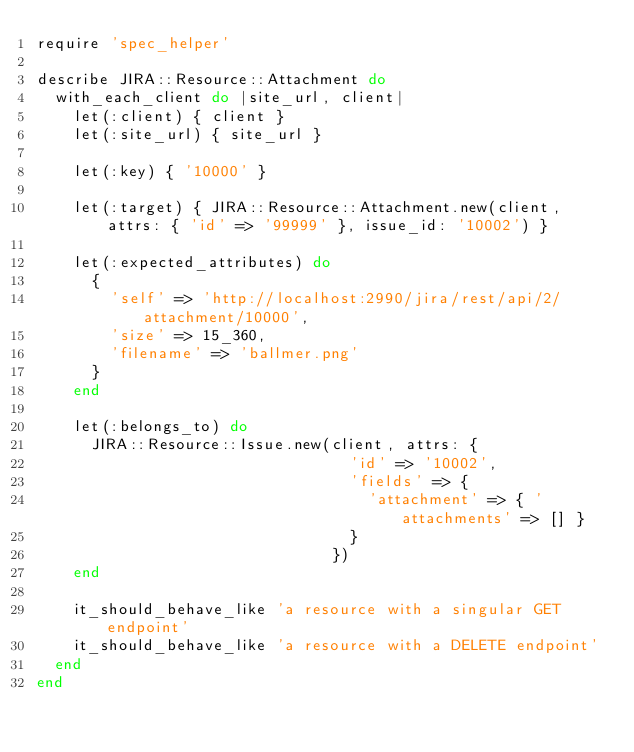<code> <loc_0><loc_0><loc_500><loc_500><_Ruby_>require 'spec_helper'

describe JIRA::Resource::Attachment do
  with_each_client do |site_url, client|
    let(:client) { client }
    let(:site_url) { site_url }

    let(:key) { '10000' }

    let(:target) { JIRA::Resource::Attachment.new(client, attrs: { 'id' => '99999' }, issue_id: '10002') }

    let(:expected_attributes) do
      {
        'self' => 'http://localhost:2990/jira/rest/api/2/attachment/10000',
        'size' => 15_360,
        'filename' => 'ballmer.png'
      }
    end

    let(:belongs_to) do
      JIRA::Resource::Issue.new(client, attrs: {
                                  'id' => '10002',
                                  'fields' => {
                                    'attachment' => { 'attachments' => [] }
                                  }
                                })
    end

    it_should_behave_like 'a resource with a singular GET endpoint'
    it_should_behave_like 'a resource with a DELETE endpoint'
  end
end
</code> 